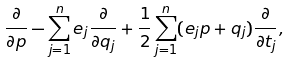Convert formula to latex. <formula><loc_0><loc_0><loc_500><loc_500>\frac { \partial } { \partial p } - \sum _ { j = 1 } ^ { n } e _ { j } \frac { \partial } { \partial q _ { j } } + \frac { 1 } { 2 } \sum _ { j = 1 } ^ { n } ( e _ { j } p + q _ { j } ) \frac { \partial } { \partial t _ { j } } ,</formula> 